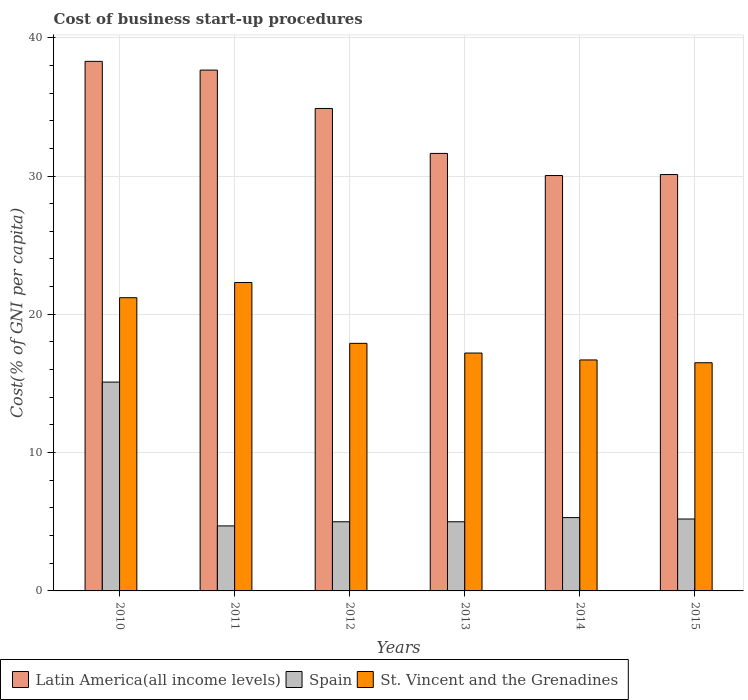How many bars are there on the 4th tick from the right?
Keep it short and to the point. 3. What is the label of the 3rd group of bars from the left?
Offer a terse response. 2012. In how many cases, is the number of bars for a given year not equal to the number of legend labels?
Keep it short and to the point. 0. What is the cost of business start-up procedures in St. Vincent and the Grenadines in 2011?
Your response must be concise. 22.3. Across all years, what is the maximum cost of business start-up procedures in Latin America(all income levels)?
Your answer should be compact. 38.29. Across all years, what is the minimum cost of business start-up procedures in Spain?
Your answer should be very brief. 4.7. In which year was the cost of business start-up procedures in St. Vincent and the Grenadines minimum?
Provide a succinct answer. 2015. What is the total cost of business start-up procedures in St. Vincent and the Grenadines in the graph?
Ensure brevity in your answer.  111.8. What is the difference between the cost of business start-up procedures in Latin America(all income levels) in 2012 and that in 2013?
Provide a short and direct response. 3.25. What is the average cost of business start-up procedures in St. Vincent and the Grenadines per year?
Your answer should be very brief. 18.63. In the year 2012, what is the difference between the cost of business start-up procedures in St. Vincent and the Grenadines and cost of business start-up procedures in Latin America(all income levels)?
Your response must be concise. -16.98. In how many years, is the cost of business start-up procedures in Latin America(all income levels) greater than 22 %?
Your answer should be very brief. 6. What is the ratio of the cost of business start-up procedures in Spain in 2011 to that in 2012?
Your response must be concise. 0.94. Is the cost of business start-up procedures in Spain in 2011 less than that in 2015?
Give a very brief answer. Yes. Is the difference between the cost of business start-up procedures in St. Vincent and the Grenadines in 2011 and 2012 greater than the difference between the cost of business start-up procedures in Latin America(all income levels) in 2011 and 2012?
Provide a short and direct response. Yes. What is the difference between the highest and the second highest cost of business start-up procedures in Latin America(all income levels)?
Offer a very short reply. 0.63. What is the difference between the highest and the lowest cost of business start-up procedures in St. Vincent and the Grenadines?
Your answer should be compact. 5.8. Is the sum of the cost of business start-up procedures in Spain in 2012 and 2015 greater than the maximum cost of business start-up procedures in St. Vincent and the Grenadines across all years?
Offer a terse response. No. What does the 3rd bar from the left in 2014 represents?
Give a very brief answer. St. Vincent and the Grenadines. What does the 3rd bar from the right in 2013 represents?
Ensure brevity in your answer.  Latin America(all income levels). Is it the case that in every year, the sum of the cost of business start-up procedures in St. Vincent and the Grenadines and cost of business start-up procedures in Spain is greater than the cost of business start-up procedures in Latin America(all income levels)?
Give a very brief answer. No. Are all the bars in the graph horizontal?
Your answer should be very brief. No. How many years are there in the graph?
Your response must be concise. 6. Does the graph contain any zero values?
Make the answer very short. No. How are the legend labels stacked?
Provide a short and direct response. Horizontal. What is the title of the graph?
Offer a very short reply. Cost of business start-up procedures. Does "Brazil" appear as one of the legend labels in the graph?
Your response must be concise. No. What is the label or title of the X-axis?
Offer a terse response. Years. What is the label or title of the Y-axis?
Provide a short and direct response. Cost(% of GNI per capita). What is the Cost(% of GNI per capita) of Latin America(all income levels) in 2010?
Keep it short and to the point. 38.29. What is the Cost(% of GNI per capita) in Spain in 2010?
Offer a very short reply. 15.1. What is the Cost(% of GNI per capita) of St. Vincent and the Grenadines in 2010?
Offer a very short reply. 21.2. What is the Cost(% of GNI per capita) in Latin America(all income levels) in 2011?
Offer a terse response. 37.66. What is the Cost(% of GNI per capita) in St. Vincent and the Grenadines in 2011?
Your answer should be very brief. 22.3. What is the Cost(% of GNI per capita) of Latin America(all income levels) in 2012?
Your answer should be very brief. 34.88. What is the Cost(% of GNI per capita) in St. Vincent and the Grenadines in 2012?
Your response must be concise. 17.9. What is the Cost(% of GNI per capita) in Latin America(all income levels) in 2013?
Your response must be concise. 31.63. What is the Cost(% of GNI per capita) in St. Vincent and the Grenadines in 2013?
Make the answer very short. 17.2. What is the Cost(% of GNI per capita) of Latin America(all income levels) in 2014?
Your answer should be compact. 30.03. What is the Cost(% of GNI per capita) in St. Vincent and the Grenadines in 2014?
Offer a terse response. 16.7. What is the Cost(% of GNI per capita) of Latin America(all income levels) in 2015?
Your answer should be compact. 30.11. What is the Cost(% of GNI per capita) of Spain in 2015?
Your answer should be very brief. 5.2. Across all years, what is the maximum Cost(% of GNI per capita) of Latin America(all income levels)?
Offer a very short reply. 38.29. Across all years, what is the maximum Cost(% of GNI per capita) of St. Vincent and the Grenadines?
Your answer should be compact. 22.3. Across all years, what is the minimum Cost(% of GNI per capita) in Latin America(all income levels)?
Make the answer very short. 30.03. Across all years, what is the minimum Cost(% of GNI per capita) of Spain?
Your answer should be compact. 4.7. Across all years, what is the minimum Cost(% of GNI per capita) of St. Vincent and the Grenadines?
Your answer should be compact. 16.5. What is the total Cost(% of GNI per capita) in Latin America(all income levels) in the graph?
Your answer should be compact. 202.6. What is the total Cost(% of GNI per capita) in Spain in the graph?
Your answer should be compact. 40.3. What is the total Cost(% of GNI per capita) of St. Vincent and the Grenadines in the graph?
Keep it short and to the point. 111.8. What is the difference between the Cost(% of GNI per capita) of Latin America(all income levels) in 2010 and that in 2011?
Provide a succinct answer. 0.63. What is the difference between the Cost(% of GNI per capita) of Latin America(all income levels) in 2010 and that in 2012?
Your answer should be very brief. 3.41. What is the difference between the Cost(% of GNI per capita) of St. Vincent and the Grenadines in 2010 and that in 2012?
Provide a succinct answer. 3.3. What is the difference between the Cost(% of GNI per capita) of Latin America(all income levels) in 2010 and that in 2013?
Ensure brevity in your answer.  6.66. What is the difference between the Cost(% of GNI per capita) in Spain in 2010 and that in 2013?
Your answer should be compact. 10.1. What is the difference between the Cost(% of GNI per capita) in Latin America(all income levels) in 2010 and that in 2014?
Your response must be concise. 8.26. What is the difference between the Cost(% of GNI per capita) of St. Vincent and the Grenadines in 2010 and that in 2014?
Provide a short and direct response. 4.5. What is the difference between the Cost(% of GNI per capita) of Latin America(all income levels) in 2010 and that in 2015?
Make the answer very short. 8.18. What is the difference between the Cost(% of GNI per capita) in St. Vincent and the Grenadines in 2010 and that in 2015?
Provide a short and direct response. 4.7. What is the difference between the Cost(% of GNI per capita) in Latin America(all income levels) in 2011 and that in 2012?
Your response must be concise. 2.77. What is the difference between the Cost(% of GNI per capita) in Spain in 2011 and that in 2012?
Make the answer very short. -0.3. What is the difference between the Cost(% of GNI per capita) in Latin America(all income levels) in 2011 and that in 2013?
Ensure brevity in your answer.  6.02. What is the difference between the Cost(% of GNI per capita) of Spain in 2011 and that in 2013?
Ensure brevity in your answer.  -0.3. What is the difference between the Cost(% of GNI per capita) in St. Vincent and the Grenadines in 2011 and that in 2013?
Your response must be concise. 5.1. What is the difference between the Cost(% of GNI per capita) of Latin America(all income levels) in 2011 and that in 2014?
Provide a succinct answer. 7.62. What is the difference between the Cost(% of GNI per capita) in Spain in 2011 and that in 2014?
Provide a short and direct response. -0.6. What is the difference between the Cost(% of GNI per capita) in St. Vincent and the Grenadines in 2011 and that in 2014?
Ensure brevity in your answer.  5.6. What is the difference between the Cost(% of GNI per capita) of Latin America(all income levels) in 2011 and that in 2015?
Make the answer very short. 7.55. What is the difference between the Cost(% of GNI per capita) of Spain in 2011 and that in 2015?
Offer a very short reply. -0.5. What is the difference between the Cost(% of GNI per capita) of St. Vincent and the Grenadines in 2011 and that in 2015?
Keep it short and to the point. 5.8. What is the difference between the Cost(% of GNI per capita) of Latin America(all income levels) in 2012 and that in 2013?
Your answer should be compact. 3.25. What is the difference between the Cost(% of GNI per capita) in Latin America(all income levels) in 2012 and that in 2014?
Offer a terse response. 4.85. What is the difference between the Cost(% of GNI per capita) in Latin America(all income levels) in 2012 and that in 2015?
Your response must be concise. 4.78. What is the difference between the Cost(% of GNI per capita) in St. Vincent and the Grenadines in 2012 and that in 2015?
Your answer should be compact. 1.4. What is the difference between the Cost(% of GNI per capita) of Spain in 2013 and that in 2014?
Your answer should be very brief. -0.3. What is the difference between the Cost(% of GNI per capita) of Latin America(all income levels) in 2013 and that in 2015?
Offer a very short reply. 1.53. What is the difference between the Cost(% of GNI per capita) in Spain in 2013 and that in 2015?
Your answer should be very brief. -0.2. What is the difference between the Cost(% of GNI per capita) in St. Vincent and the Grenadines in 2013 and that in 2015?
Your response must be concise. 0.7. What is the difference between the Cost(% of GNI per capita) in Latin America(all income levels) in 2014 and that in 2015?
Provide a short and direct response. -0.07. What is the difference between the Cost(% of GNI per capita) in St. Vincent and the Grenadines in 2014 and that in 2015?
Provide a short and direct response. 0.2. What is the difference between the Cost(% of GNI per capita) of Latin America(all income levels) in 2010 and the Cost(% of GNI per capita) of Spain in 2011?
Your answer should be compact. 33.59. What is the difference between the Cost(% of GNI per capita) of Latin America(all income levels) in 2010 and the Cost(% of GNI per capita) of St. Vincent and the Grenadines in 2011?
Keep it short and to the point. 15.99. What is the difference between the Cost(% of GNI per capita) in Latin America(all income levels) in 2010 and the Cost(% of GNI per capita) in Spain in 2012?
Provide a succinct answer. 33.29. What is the difference between the Cost(% of GNI per capita) in Latin America(all income levels) in 2010 and the Cost(% of GNI per capita) in St. Vincent and the Grenadines in 2012?
Your answer should be very brief. 20.39. What is the difference between the Cost(% of GNI per capita) in Latin America(all income levels) in 2010 and the Cost(% of GNI per capita) in Spain in 2013?
Provide a succinct answer. 33.29. What is the difference between the Cost(% of GNI per capita) in Latin America(all income levels) in 2010 and the Cost(% of GNI per capita) in St. Vincent and the Grenadines in 2013?
Give a very brief answer. 21.09. What is the difference between the Cost(% of GNI per capita) in Latin America(all income levels) in 2010 and the Cost(% of GNI per capita) in Spain in 2014?
Provide a short and direct response. 32.99. What is the difference between the Cost(% of GNI per capita) of Latin America(all income levels) in 2010 and the Cost(% of GNI per capita) of St. Vincent and the Grenadines in 2014?
Provide a succinct answer. 21.59. What is the difference between the Cost(% of GNI per capita) in Latin America(all income levels) in 2010 and the Cost(% of GNI per capita) in Spain in 2015?
Offer a terse response. 33.09. What is the difference between the Cost(% of GNI per capita) in Latin America(all income levels) in 2010 and the Cost(% of GNI per capita) in St. Vincent and the Grenadines in 2015?
Give a very brief answer. 21.79. What is the difference between the Cost(% of GNI per capita) of Spain in 2010 and the Cost(% of GNI per capita) of St. Vincent and the Grenadines in 2015?
Your response must be concise. -1.4. What is the difference between the Cost(% of GNI per capita) in Latin America(all income levels) in 2011 and the Cost(% of GNI per capita) in Spain in 2012?
Offer a terse response. 32.66. What is the difference between the Cost(% of GNI per capita) in Latin America(all income levels) in 2011 and the Cost(% of GNI per capita) in St. Vincent and the Grenadines in 2012?
Provide a short and direct response. 19.76. What is the difference between the Cost(% of GNI per capita) of Spain in 2011 and the Cost(% of GNI per capita) of St. Vincent and the Grenadines in 2012?
Your response must be concise. -13.2. What is the difference between the Cost(% of GNI per capita) in Latin America(all income levels) in 2011 and the Cost(% of GNI per capita) in Spain in 2013?
Ensure brevity in your answer.  32.66. What is the difference between the Cost(% of GNI per capita) in Latin America(all income levels) in 2011 and the Cost(% of GNI per capita) in St. Vincent and the Grenadines in 2013?
Your answer should be compact. 20.46. What is the difference between the Cost(% of GNI per capita) in Spain in 2011 and the Cost(% of GNI per capita) in St. Vincent and the Grenadines in 2013?
Provide a succinct answer. -12.5. What is the difference between the Cost(% of GNI per capita) in Latin America(all income levels) in 2011 and the Cost(% of GNI per capita) in Spain in 2014?
Ensure brevity in your answer.  32.36. What is the difference between the Cost(% of GNI per capita) of Latin America(all income levels) in 2011 and the Cost(% of GNI per capita) of St. Vincent and the Grenadines in 2014?
Provide a short and direct response. 20.96. What is the difference between the Cost(% of GNI per capita) in Spain in 2011 and the Cost(% of GNI per capita) in St. Vincent and the Grenadines in 2014?
Your response must be concise. -12. What is the difference between the Cost(% of GNI per capita) in Latin America(all income levels) in 2011 and the Cost(% of GNI per capita) in Spain in 2015?
Your answer should be very brief. 32.46. What is the difference between the Cost(% of GNI per capita) in Latin America(all income levels) in 2011 and the Cost(% of GNI per capita) in St. Vincent and the Grenadines in 2015?
Keep it short and to the point. 21.16. What is the difference between the Cost(% of GNI per capita) of Latin America(all income levels) in 2012 and the Cost(% of GNI per capita) of Spain in 2013?
Your response must be concise. 29.88. What is the difference between the Cost(% of GNI per capita) of Latin America(all income levels) in 2012 and the Cost(% of GNI per capita) of St. Vincent and the Grenadines in 2013?
Your response must be concise. 17.68. What is the difference between the Cost(% of GNI per capita) in Spain in 2012 and the Cost(% of GNI per capita) in St. Vincent and the Grenadines in 2013?
Your response must be concise. -12.2. What is the difference between the Cost(% of GNI per capita) in Latin America(all income levels) in 2012 and the Cost(% of GNI per capita) in Spain in 2014?
Offer a very short reply. 29.58. What is the difference between the Cost(% of GNI per capita) of Latin America(all income levels) in 2012 and the Cost(% of GNI per capita) of St. Vincent and the Grenadines in 2014?
Provide a short and direct response. 18.18. What is the difference between the Cost(% of GNI per capita) in Spain in 2012 and the Cost(% of GNI per capita) in St. Vincent and the Grenadines in 2014?
Your answer should be very brief. -11.7. What is the difference between the Cost(% of GNI per capita) in Latin America(all income levels) in 2012 and the Cost(% of GNI per capita) in Spain in 2015?
Your answer should be very brief. 29.68. What is the difference between the Cost(% of GNI per capita) of Latin America(all income levels) in 2012 and the Cost(% of GNI per capita) of St. Vincent and the Grenadines in 2015?
Make the answer very short. 18.38. What is the difference between the Cost(% of GNI per capita) of Latin America(all income levels) in 2013 and the Cost(% of GNI per capita) of Spain in 2014?
Offer a very short reply. 26.33. What is the difference between the Cost(% of GNI per capita) in Latin America(all income levels) in 2013 and the Cost(% of GNI per capita) in St. Vincent and the Grenadines in 2014?
Provide a short and direct response. 14.93. What is the difference between the Cost(% of GNI per capita) of Spain in 2013 and the Cost(% of GNI per capita) of St. Vincent and the Grenadines in 2014?
Give a very brief answer. -11.7. What is the difference between the Cost(% of GNI per capita) of Latin America(all income levels) in 2013 and the Cost(% of GNI per capita) of Spain in 2015?
Keep it short and to the point. 26.43. What is the difference between the Cost(% of GNI per capita) in Latin America(all income levels) in 2013 and the Cost(% of GNI per capita) in St. Vincent and the Grenadines in 2015?
Ensure brevity in your answer.  15.13. What is the difference between the Cost(% of GNI per capita) of Spain in 2013 and the Cost(% of GNI per capita) of St. Vincent and the Grenadines in 2015?
Make the answer very short. -11.5. What is the difference between the Cost(% of GNI per capita) in Latin America(all income levels) in 2014 and the Cost(% of GNI per capita) in Spain in 2015?
Offer a terse response. 24.83. What is the difference between the Cost(% of GNI per capita) in Latin America(all income levels) in 2014 and the Cost(% of GNI per capita) in St. Vincent and the Grenadines in 2015?
Provide a succinct answer. 13.53. What is the difference between the Cost(% of GNI per capita) of Spain in 2014 and the Cost(% of GNI per capita) of St. Vincent and the Grenadines in 2015?
Provide a succinct answer. -11.2. What is the average Cost(% of GNI per capita) in Latin America(all income levels) per year?
Your answer should be compact. 33.77. What is the average Cost(% of GNI per capita) of Spain per year?
Offer a very short reply. 6.72. What is the average Cost(% of GNI per capita) in St. Vincent and the Grenadines per year?
Your response must be concise. 18.63. In the year 2010, what is the difference between the Cost(% of GNI per capita) in Latin America(all income levels) and Cost(% of GNI per capita) in Spain?
Your answer should be very brief. 23.19. In the year 2010, what is the difference between the Cost(% of GNI per capita) in Latin America(all income levels) and Cost(% of GNI per capita) in St. Vincent and the Grenadines?
Make the answer very short. 17.09. In the year 2011, what is the difference between the Cost(% of GNI per capita) of Latin America(all income levels) and Cost(% of GNI per capita) of Spain?
Offer a terse response. 32.96. In the year 2011, what is the difference between the Cost(% of GNI per capita) of Latin America(all income levels) and Cost(% of GNI per capita) of St. Vincent and the Grenadines?
Your answer should be compact. 15.36. In the year 2011, what is the difference between the Cost(% of GNI per capita) of Spain and Cost(% of GNI per capita) of St. Vincent and the Grenadines?
Your response must be concise. -17.6. In the year 2012, what is the difference between the Cost(% of GNI per capita) in Latin America(all income levels) and Cost(% of GNI per capita) in Spain?
Your answer should be compact. 29.88. In the year 2012, what is the difference between the Cost(% of GNI per capita) of Latin America(all income levels) and Cost(% of GNI per capita) of St. Vincent and the Grenadines?
Your answer should be very brief. 16.98. In the year 2012, what is the difference between the Cost(% of GNI per capita) in Spain and Cost(% of GNI per capita) in St. Vincent and the Grenadines?
Provide a succinct answer. -12.9. In the year 2013, what is the difference between the Cost(% of GNI per capita) in Latin America(all income levels) and Cost(% of GNI per capita) in Spain?
Provide a short and direct response. 26.63. In the year 2013, what is the difference between the Cost(% of GNI per capita) in Latin America(all income levels) and Cost(% of GNI per capita) in St. Vincent and the Grenadines?
Your answer should be compact. 14.43. In the year 2013, what is the difference between the Cost(% of GNI per capita) in Spain and Cost(% of GNI per capita) in St. Vincent and the Grenadines?
Offer a terse response. -12.2. In the year 2014, what is the difference between the Cost(% of GNI per capita) in Latin America(all income levels) and Cost(% of GNI per capita) in Spain?
Keep it short and to the point. 24.73. In the year 2014, what is the difference between the Cost(% of GNI per capita) of Latin America(all income levels) and Cost(% of GNI per capita) of St. Vincent and the Grenadines?
Your response must be concise. 13.33. In the year 2015, what is the difference between the Cost(% of GNI per capita) in Latin America(all income levels) and Cost(% of GNI per capita) in Spain?
Provide a short and direct response. 24.91. In the year 2015, what is the difference between the Cost(% of GNI per capita) in Latin America(all income levels) and Cost(% of GNI per capita) in St. Vincent and the Grenadines?
Provide a short and direct response. 13.61. In the year 2015, what is the difference between the Cost(% of GNI per capita) of Spain and Cost(% of GNI per capita) of St. Vincent and the Grenadines?
Ensure brevity in your answer.  -11.3. What is the ratio of the Cost(% of GNI per capita) in Latin America(all income levels) in 2010 to that in 2011?
Provide a succinct answer. 1.02. What is the ratio of the Cost(% of GNI per capita) of Spain in 2010 to that in 2011?
Keep it short and to the point. 3.21. What is the ratio of the Cost(% of GNI per capita) in St. Vincent and the Grenadines in 2010 to that in 2011?
Ensure brevity in your answer.  0.95. What is the ratio of the Cost(% of GNI per capita) of Latin America(all income levels) in 2010 to that in 2012?
Your answer should be compact. 1.1. What is the ratio of the Cost(% of GNI per capita) of Spain in 2010 to that in 2012?
Your response must be concise. 3.02. What is the ratio of the Cost(% of GNI per capita) of St. Vincent and the Grenadines in 2010 to that in 2012?
Provide a succinct answer. 1.18. What is the ratio of the Cost(% of GNI per capita) in Latin America(all income levels) in 2010 to that in 2013?
Make the answer very short. 1.21. What is the ratio of the Cost(% of GNI per capita) of Spain in 2010 to that in 2013?
Provide a succinct answer. 3.02. What is the ratio of the Cost(% of GNI per capita) of St. Vincent and the Grenadines in 2010 to that in 2013?
Offer a terse response. 1.23. What is the ratio of the Cost(% of GNI per capita) in Latin America(all income levels) in 2010 to that in 2014?
Provide a short and direct response. 1.27. What is the ratio of the Cost(% of GNI per capita) of Spain in 2010 to that in 2014?
Your answer should be very brief. 2.85. What is the ratio of the Cost(% of GNI per capita) of St. Vincent and the Grenadines in 2010 to that in 2014?
Offer a very short reply. 1.27. What is the ratio of the Cost(% of GNI per capita) of Latin America(all income levels) in 2010 to that in 2015?
Your response must be concise. 1.27. What is the ratio of the Cost(% of GNI per capita) of Spain in 2010 to that in 2015?
Offer a terse response. 2.9. What is the ratio of the Cost(% of GNI per capita) of St. Vincent and the Grenadines in 2010 to that in 2015?
Provide a short and direct response. 1.28. What is the ratio of the Cost(% of GNI per capita) of Latin America(all income levels) in 2011 to that in 2012?
Give a very brief answer. 1.08. What is the ratio of the Cost(% of GNI per capita) of St. Vincent and the Grenadines in 2011 to that in 2012?
Keep it short and to the point. 1.25. What is the ratio of the Cost(% of GNI per capita) in Latin America(all income levels) in 2011 to that in 2013?
Offer a terse response. 1.19. What is the ratio of the Cost(% of GNI per capita) in Spain in 2011 to that in 2013?
Your response must be concise. 0.94. What is the ratio of the Cost(% of GNI per capita) in St. Vincent and the Grenadines in 2011 to that in 2013?
Provide a short and direct response. 1.3. What is the ratio of the Cost(% of GNI per capita) of Latin America(all income levels) in 2011 to that in 2014?
Offer a terse response. 1.25. What is the ratio of the Cost(% of GNI per capita) of Spain in 2011 to that in 2014?
Offer a very short reply. 0.89. What is the ratio of the Cost(% of GNI per capita) of St. Vincent and the Grenadines in 2011 to that in 2014?
Provide a succinct answer. 1.34. What is the ratio of the Cost(% of GNI per capita) in Latin America(all income levels) in 2011 to that in 2015?
Ensure brevity in your answer.  1.25. What is the ratio of the Cost(% of GNI per capita) in Spain in 2011 to that in 2015?
Offer a terse response. 0.9. What is the ratio of the Cost(% of GNI per capita) in St. Vincent and the Grenadines in 2011 to that in 2015?
Keep it short and to the point. 1.35. What is the ratio of the Cost(% of GNI per capita) of Latin America(all income levels) in 2012 to that in 2013?
Give a very brief answer. 1.1. What is the ratio of the Cost(% of GNI per capita) of St. Vincent and the Grenadines in 2012 to that in 2013?
Offer a terse response. 1.04. What is the ratio of the Cost(% of GNI per capita) in Latin America(all income levels) in 2012 to that in 2014?
Your response must be concise. 1.16. What is the ratio of the Cost(% of GNI per capita) of Spain in 2012 to that in 2014?
Make the answer very short. 0.94. What is the ratio of the Cost(% of GNI per capita) in St. Vincent and the Grenadines in 2012 to that in 2014?
Provide a short and direct response. 1.07. What is the ratio of the Cost(% of GNI per capita) of Latin America(all income levels) in 2012 to that in 2015?
Provide a succinct answer. 1.16. What is the ratio of the Cost(% of GNI per capita) of Spain in 2012 to that in 2015?
Keep it short and to the point. 0.96. What is the ratio of the Cost(% of GNI per capita) of St. Vincent and the Grenadines in 2012 to that in 2015?
Keep it short and to the point. 1.08. What is the ratio of the Cost(% of GNI per capita) of Latin America(all income levels) in 2013 to that in 2014?
Offer a very short reply. 1.05. What is the ratio of the Cost(% of GNI per capita) in Spain in 2013 to that in 2014?
Offer a terse response. 0.94. What is the ratio of the Cost(% of GNI per capita) of St. Vincent and the Grenadines in 2013 to that in 2014?
Offer a terse response. 1.03. What is the ratio of the Cost(% of GNI per capita) of Latin America(all income levels) in 2013 to that in 2015?
Provide a succinct answer. 1.05. What is the ratio of the Cost(% of GNI per capita) in Spain in 2013 to that in 2015?
Offer a very short reply. 0.96. What is the ratio of the Cost(% of GNI per capita) of St. Vincent and the Grenadines in 2013 to that in 2015?
Your answer should be compact. 1.04. What is the ratio of the Cost(% of GNI per capita) in Spain in 2014 to that in 2015?
Your answer should be very brief. 1.02. What is the ratio of the Cost(% of GNI per capita) in St. Vincent and the Grenadines in 2014 to that in 2015?
Give a very brief answer. 1.01. What is the difference between the highest and the second highest Cost(% of GNI per capita) in Latin America(all income levels)?
Offer a very short reply. 0.63. What is the difference between the highest and the second highest Cost(% of GNI per capita) in Spain?
Your answer should be compact. 9.8. What is the difference between the highest and the second highest Cost(% of GNI per capita) of St. Vincent and the Grenadines?
Your response must be concise. 1.1. What is the difference between the highest and the lowest Cost(% of GNI per capita) in Latin America(all income levels)?
Provide a succinct answer. 8.26. What is the difference between the highest and the lowest Cost(% of GNI per capita) in Spain?
Your response must be concise. 10.4. What is the difference between the highest and the lowest Cost(% of GNI per capita) in St. Vincent and the Grenadines?
Your answer should be compact. 5.8. 